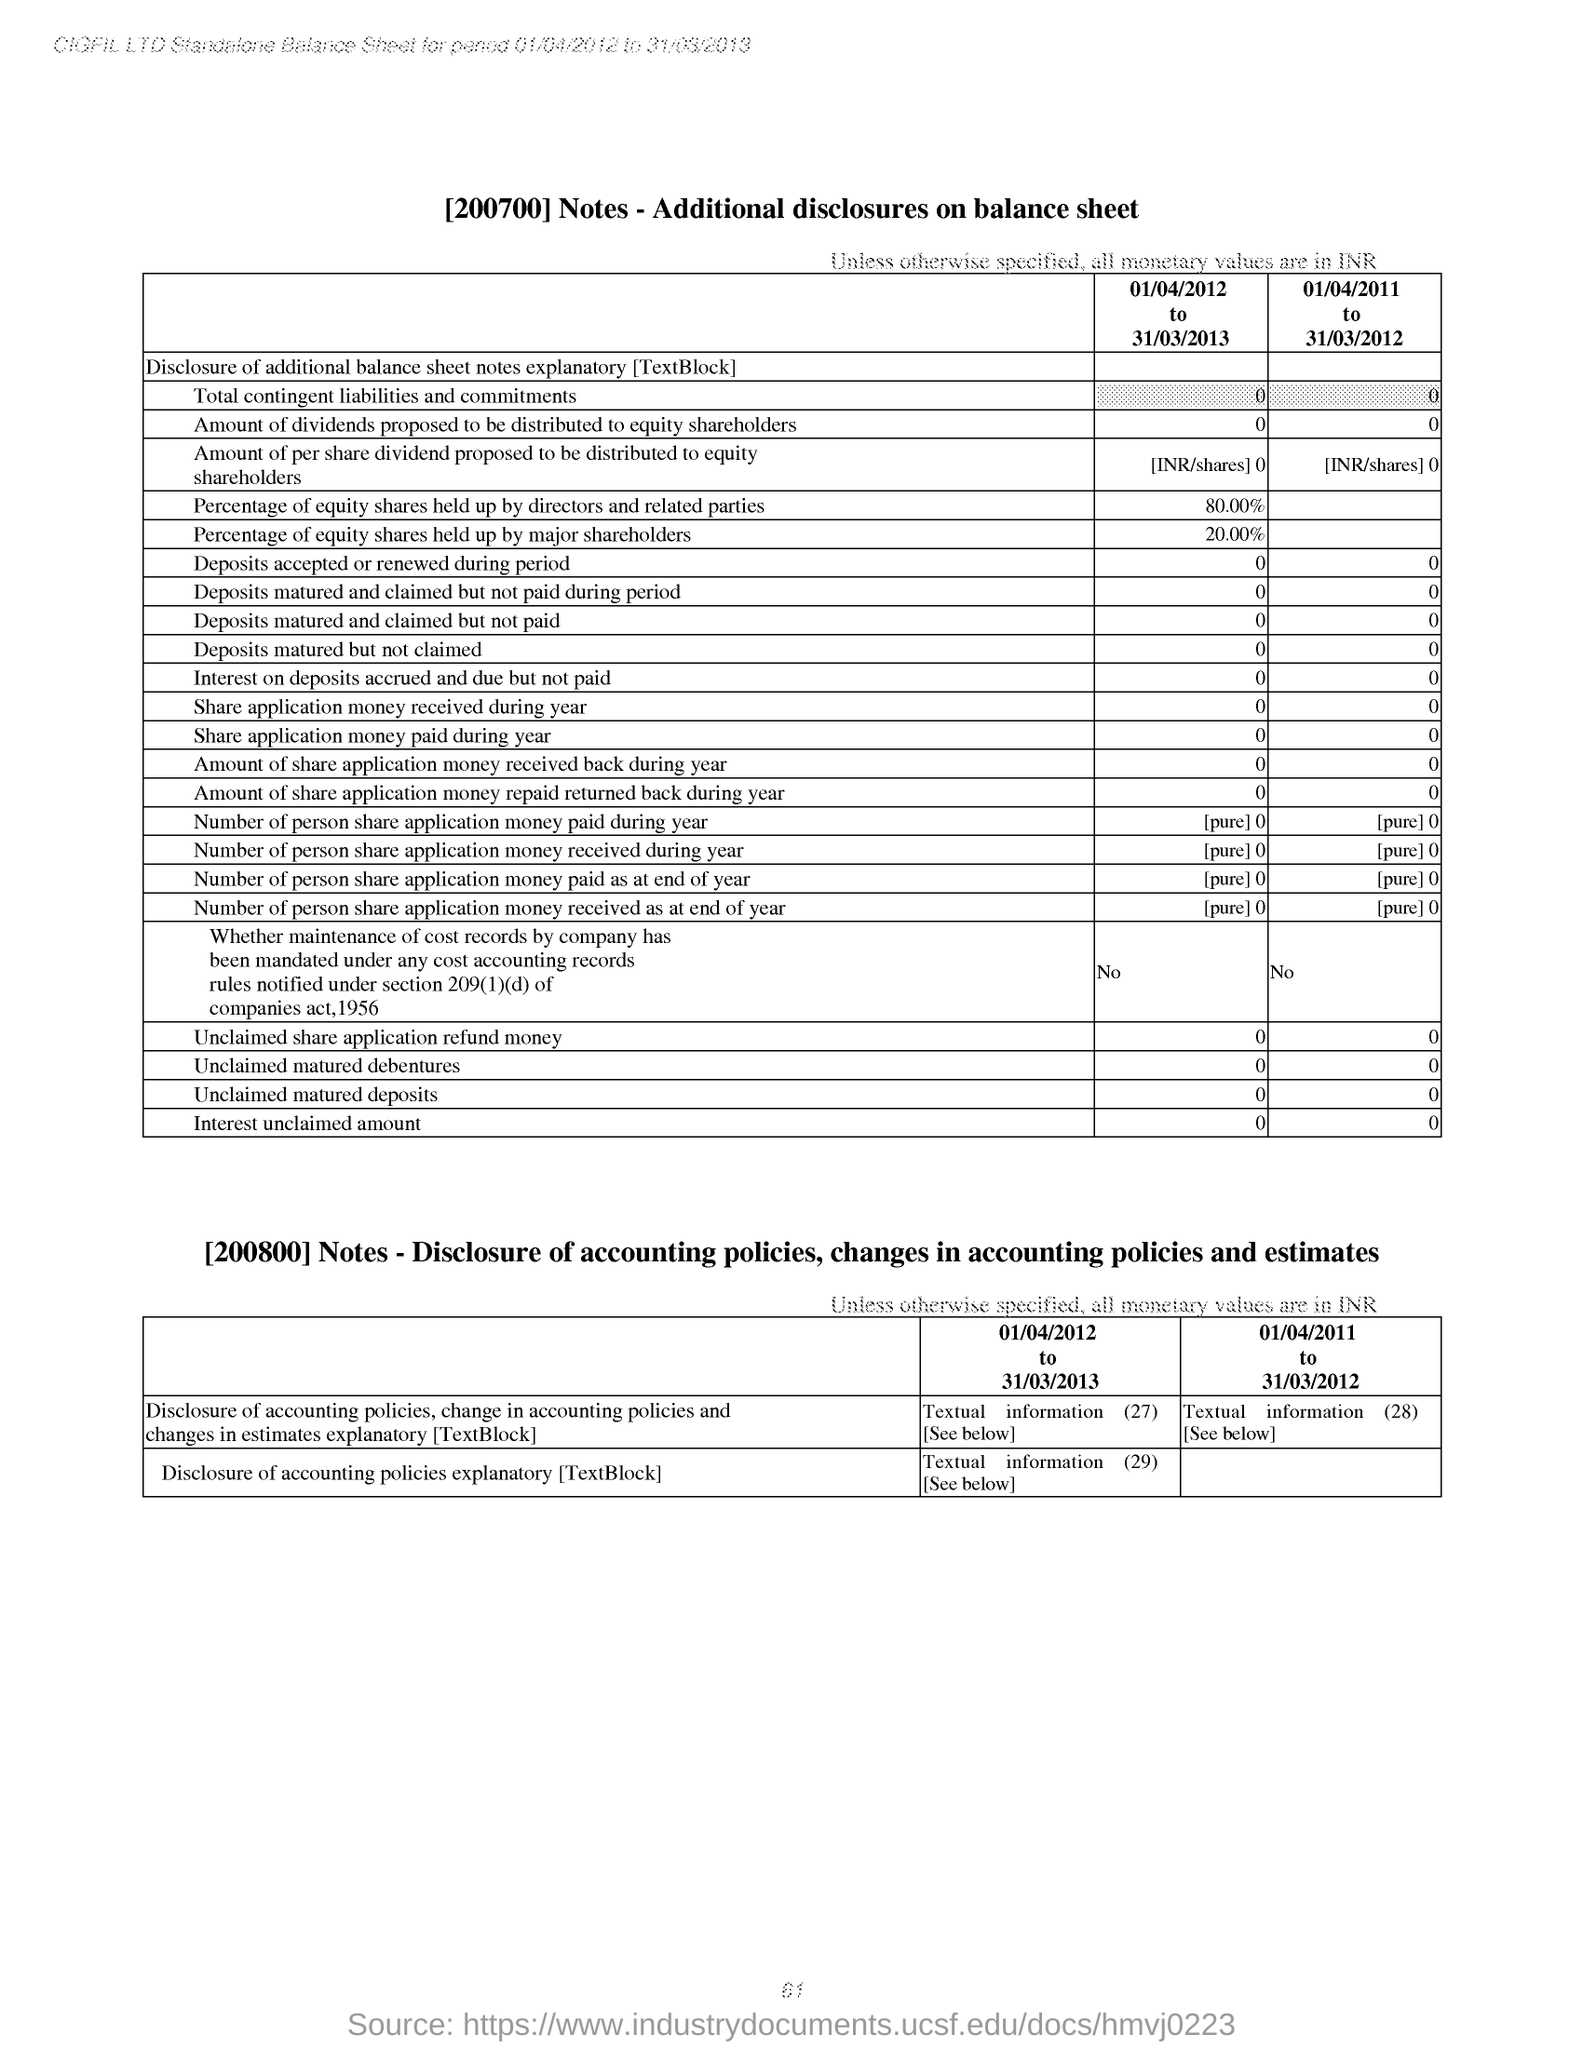What is the Percentage of equity shares held up by major shareholders from 01/04/2012 to 31/03/2013? The percentage of equity shares held by major shareholders between April 1, 2012, to March 31, 2013, was 20.00%. This indicates that during this fiscal year, one-fifth of the company's equity was controlled by major stakeholders, reflecting a significant interest and potential influence in the company's governance and decision-making processes. 